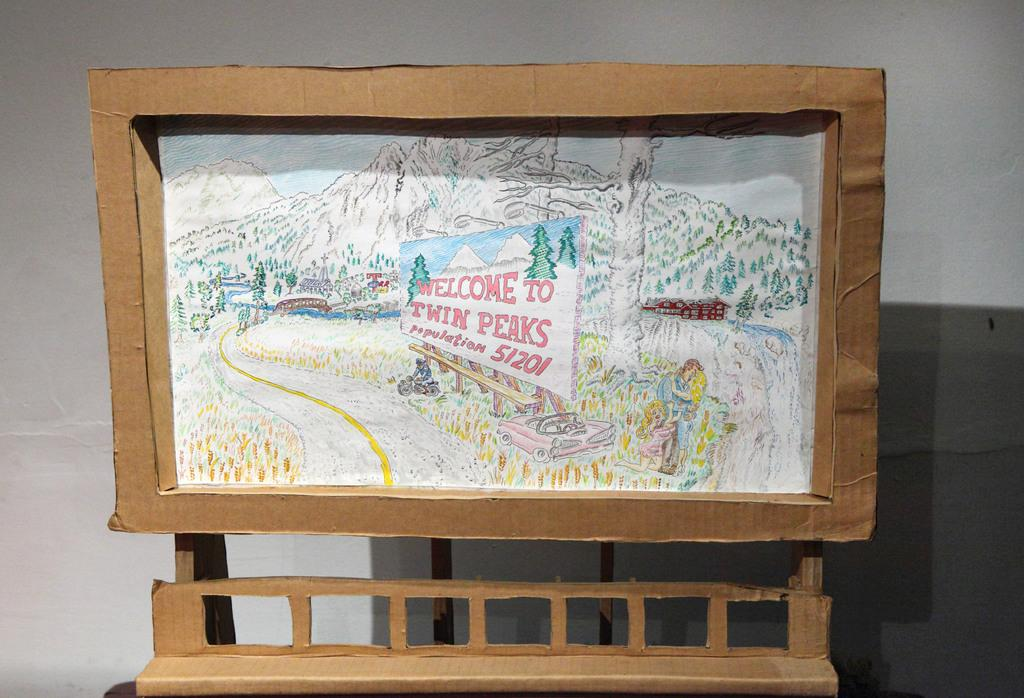<image>
Create a compact narrative representing the image presented. A cardboard frame has a drawing in it that shows a mountain and sign that says Welcome to Twin Peaks. 